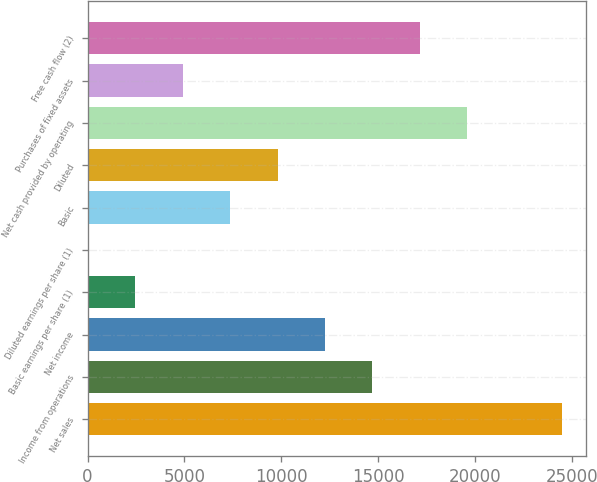Convert chart. <chart><loc_0><loc_0><loc_500><loc_500><bar_chart><fcel>Net sales<fcel>Income from operations<fcel>Net income<fcel>Basic earnings per share (1)<fcel>Diluted earnings per share (1)<fcel>Basic<fcel>Diluted<fcel>Net cash provided by operating<fcel>Purchases of fixed assets<fcel>Free cash flow (2)<nl><fcel>24509<fcel>14706.2<fcel>12255.5<fcel>2452.74<fcel>2.04<fcel>7354.14<fcel>9804.84<fcel>19607.6<fcel>4903.44<fcel>17156.9<nl></chart> 